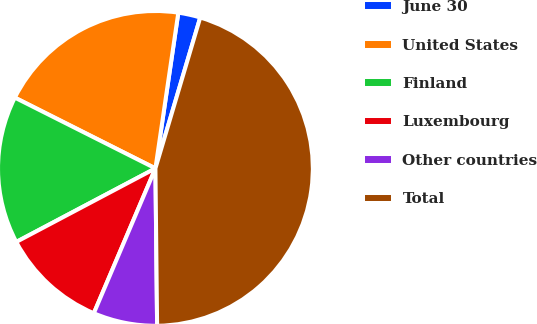Convert chart. <chart><loc_0><loc_0><loc_500><loc_500><pie_chart><fcel>June 30<fcel>United States<fcel>Finland<fcel>Luxembourg<fcel>Other countries<fcel>Total<nl><fcel>2.27%<fcel>19.9%<fcel>15.16%<fcel>10.86%<fcel>6.57%<fcel>45.23%<nl></chart> 